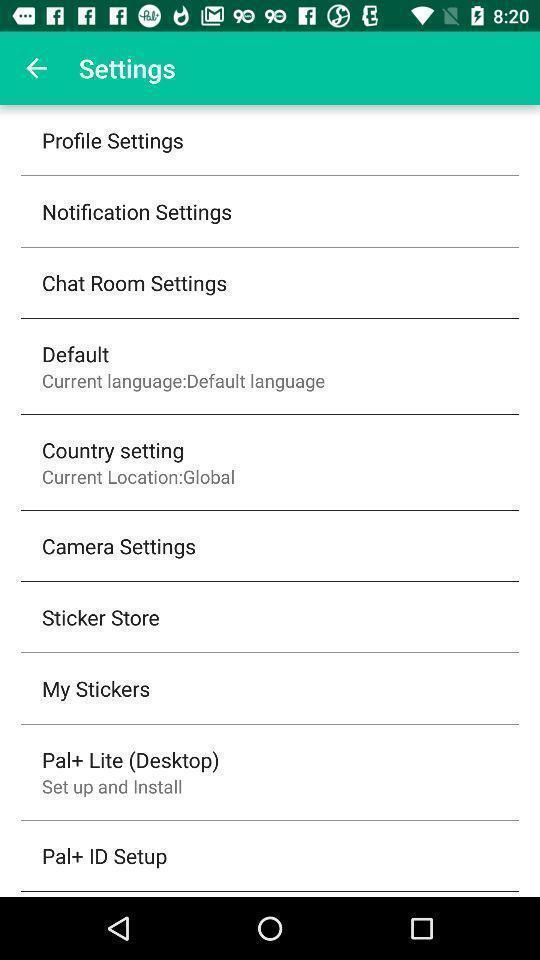Tell me what you see in this picture. Settings page displaying various options. 